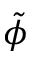<formula> <loc_0><loc_0><loc_500><loc_500>\tilde { \phi }</formula> 